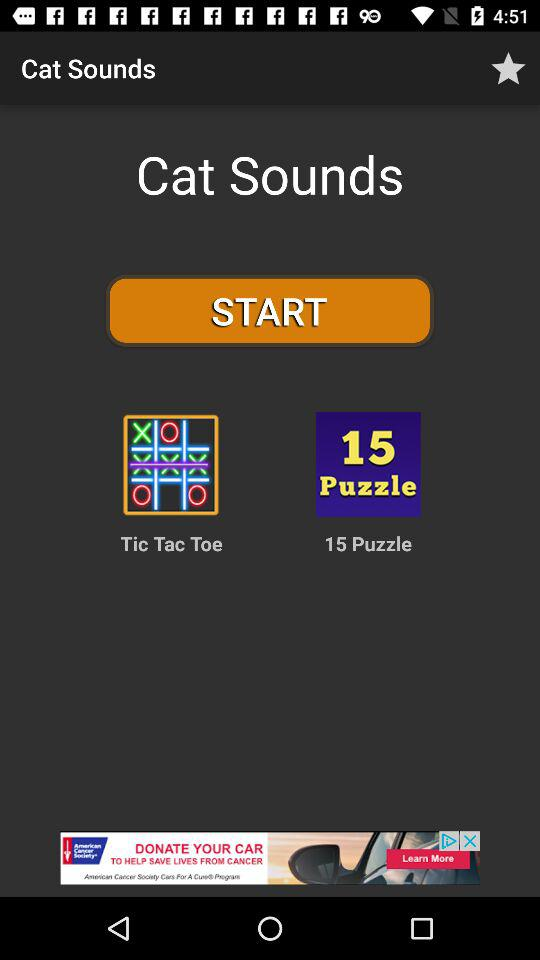What is the name of the application? The name of the application is "Cat Sounds". 